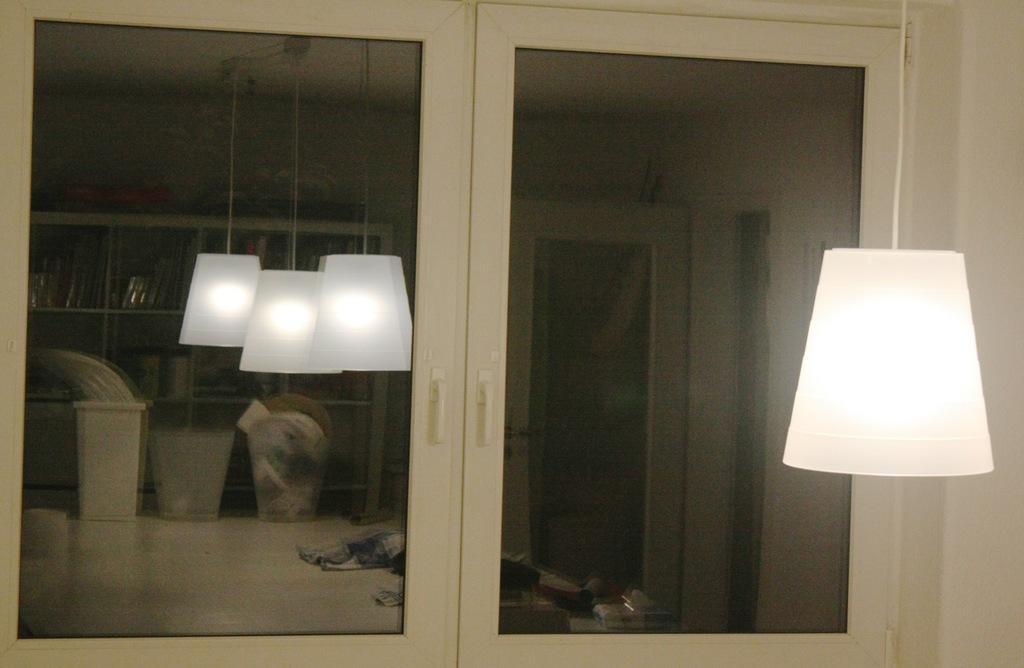Describe this image in one or two sentences. In this image I can see a lamp hanging on the right. There is a glass window on which there is a reflection of 3 lamps and shelves at the back. 